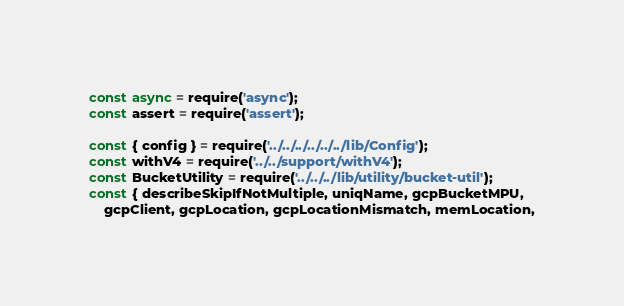Convert code to text. <code><loc_0><loc_0><loc_500><loc_500><_JavaScript_>const async = require('async');
const assert = require('assert');

const { config } = require('../../../../../../lib/Config');
const withV4 = require('../../support/withV4');
const BucketUtility = require('../../../lib/utility/bucket-util');
const { describeSkipIfNotMultiple, uniqName, gcpBucketMPU,
    gcpClient, gcpLocation, gcpLocationMismatch, memLocation,</code> 